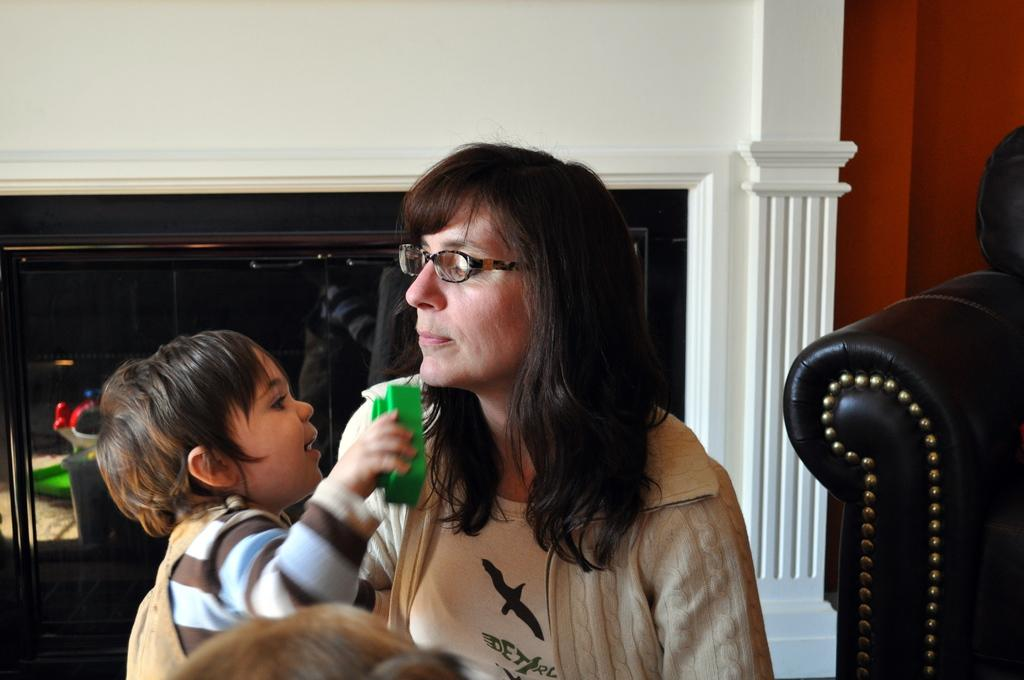How many people are present in the room in the image? There are two persons in the room. Can you describe one of the persons in the room? One of the persons is wearing spectacles. What can be seen in the background of the room? There is a wall and a pillar in the background of the room. What type of soap is being used by the person wearing spectacles in the image? There is no soap present in the image, and it is not mentioned that the person wearing spectacles is using any soap. 